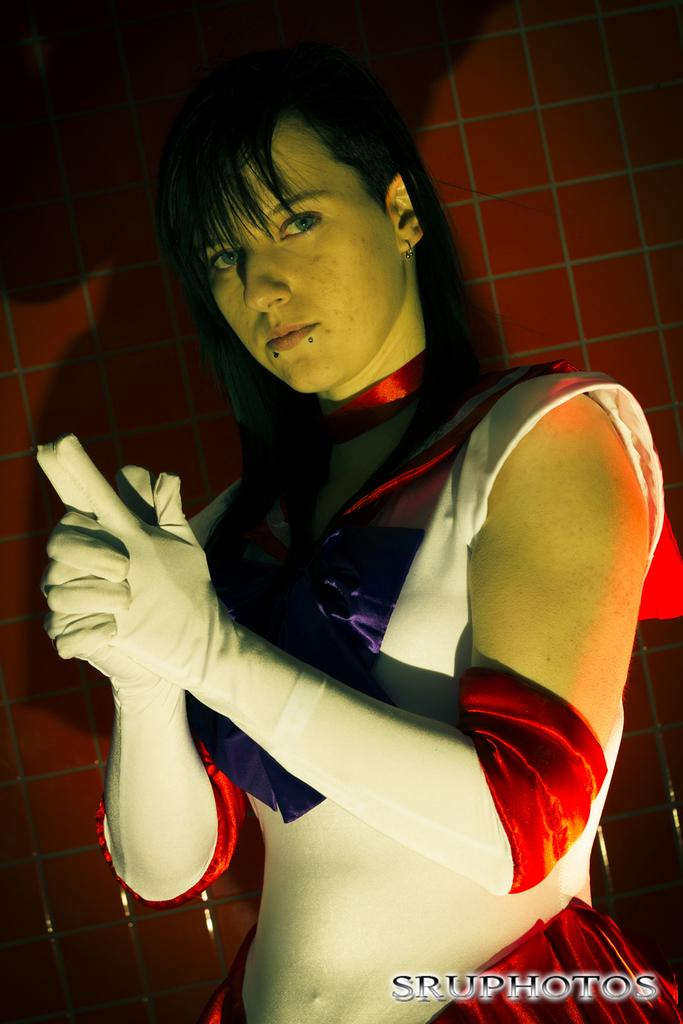Who is present in the image? There is a woman in the image. What is the woman wearing? The woman is wearing a red, violet, and white colored dress. How is the woman described? The woman is described as stunning. What can be seen in the background of the image? There is a brown colored wall in the background of the image. What type of seed is the woman holding in the image? There is no seed present in the image; the woman is not holding anything. Can you see any horns on the woman in the image? No, there are no horns visible on the woman in the image. 